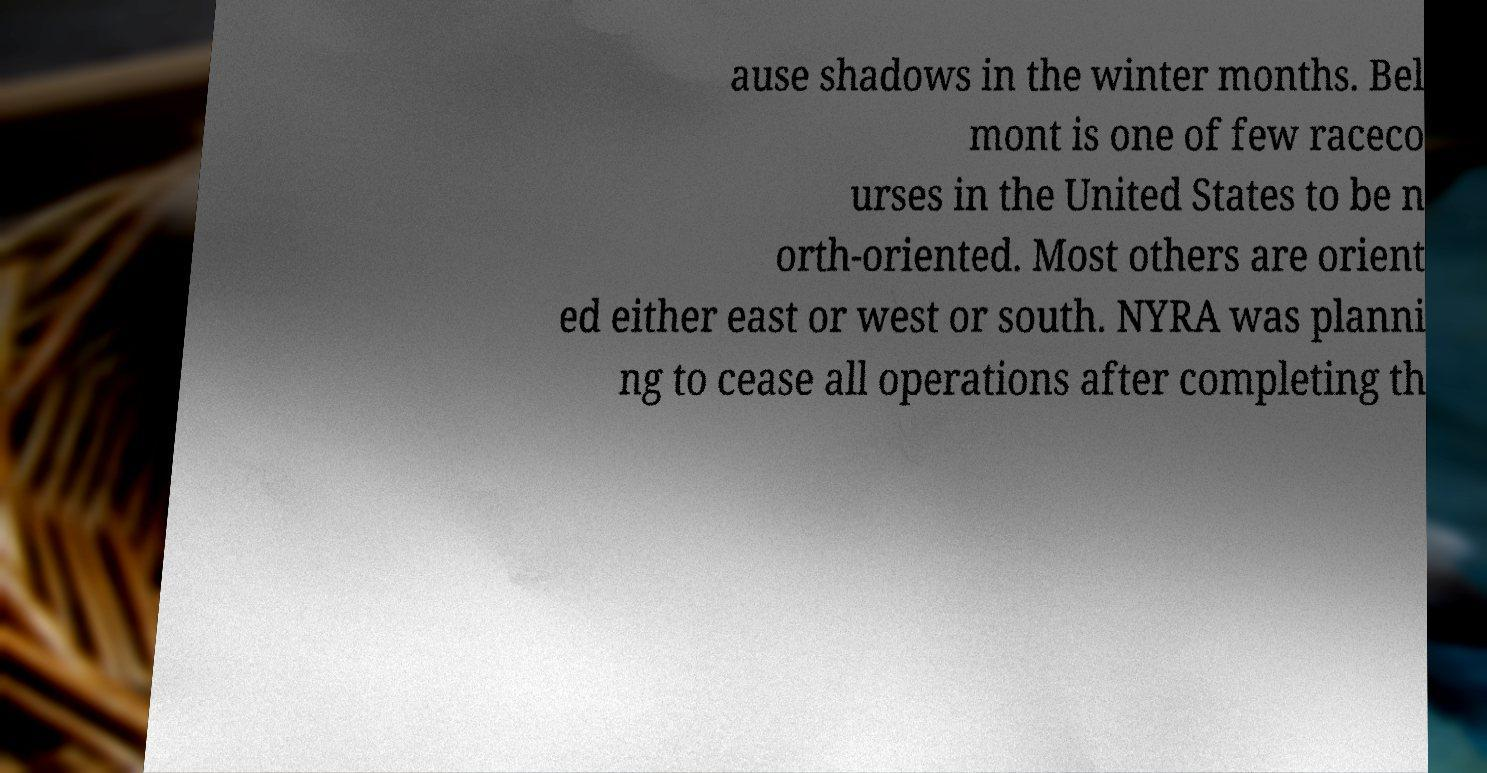Could you extract and type out the text from this image? ause shadows in the winter months. Bel mont is one of few raceco urses in the United States to be n orth-oriented. Most others are orient ed either east or west or south. NYRA was planni ng to cease all operations after completing th 